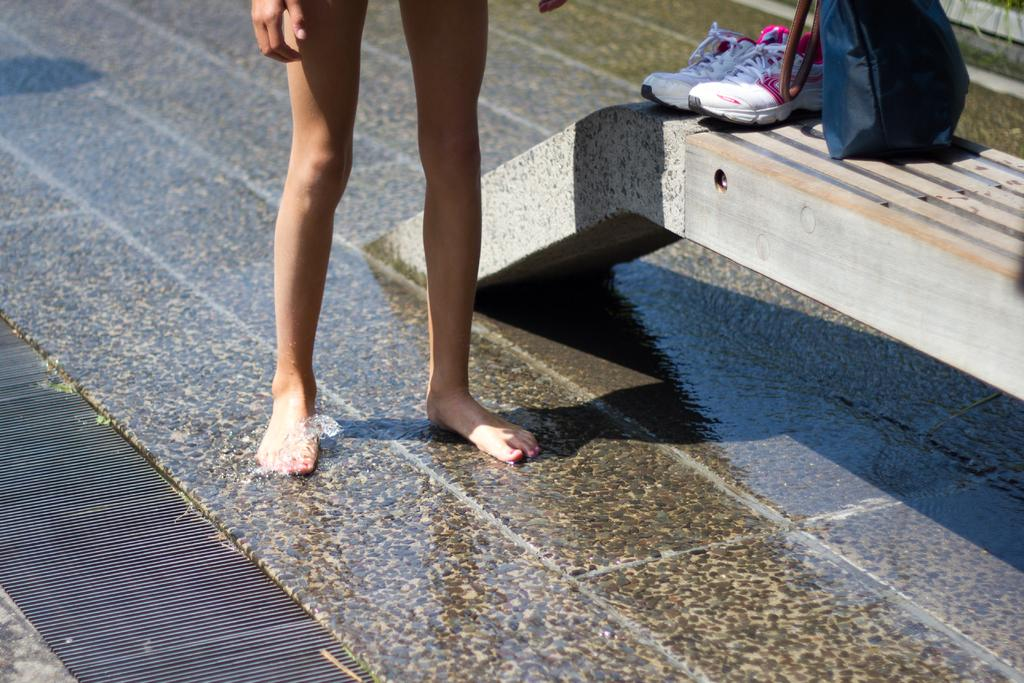What is the condition of the ground in the image? The ground in the image is wet. What part of the person can be seen in the image? The person's legs are visible in the image. Where are the shoes located in the image? The shoes are in the right corner of the image. What object is the handbag placed on in the image? The handbag is placed on an object in the right corner of the image. Can you describe the ocean in the image? There is no ocean present in the image; it features a person standing on wet ground. What type of nerve is visible in the image? There are no nerves visible in the image; it shows a person standing on wet ground with a pair of shoes and a handbag in the right corner. 